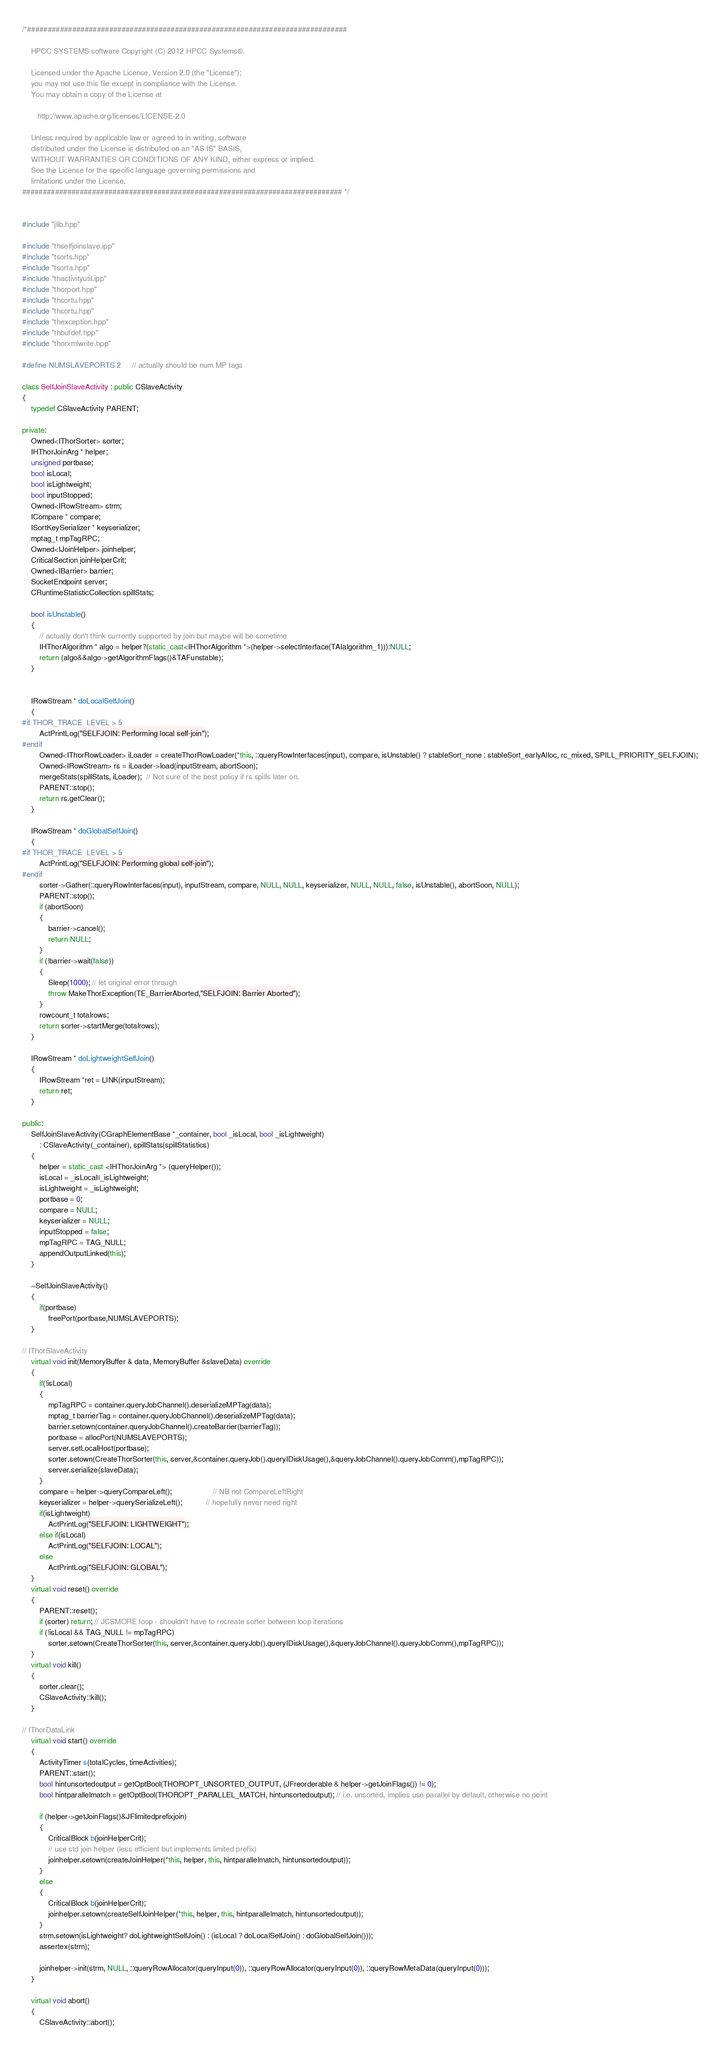<code> <loc_0><loc_0><loc_500><loc_500><_C++_>/*##############################################################################

    HPCC SYSTEMS software Copyright (C) 2012 HPCC Systems®.

    Licensed under the Apache License, Version 2.0 (the "License");
    you may not use this file except in compliance with the License.
    You may obtain a copy of the License at

       http://www.apache.org/licenses/LICENSE-2.0

    Unless required by applicable law or agreed to in writing, software
    distributed under the License is distributed on an "AS IS" BASIS,
    WITHOUT WARRANTIES OR CONDITIONS OF ANY KIND, either express or implied.
    See the License for the specific language governing permissions and
    limitations under the License.
############################################################################## */


#include "jlib.hpp"

#include "thselfjoinslave.ipp"
#include "tsorts.hpp"
#include "tsorta.hpp"
#include "thactivityutil.ipp"
#include "thorport.hpp"
#include "thsortu.hpp"
#include "thsortu.hpp"
#include "thexception.hpp"
#include "thbufdef.hpp"
#include "thorxmlwrite.hpp"

#define NUMSLAVEPORTS 2     // actually should be num MP tags

class SelfJoinSlaveActivity : public CSlaveActivity
{
    typedef CSlaveActivity PARENT;

private:
    Owned<IThorSorter> sorter;
    IHThorJoinArg * helper;
    unsigned portbase;
    bool isLocal;
    bool isLightweight;
    bool inputStopped;
    Owned<IRowStream> strm;     
    ICompare * compare;
    ISortKeySerializer * keyserializer;
    mptag_t mpTagRPC;
    Owned<IJoinHelper> joinhelper;
    CriticalSection joinHelperCrit;
    Owned<IBarrier> barrier;
    SocketEndpoint server;
    CRuntimeStatisticCollection spillStats;

    bool isUnstable()
    {
        // actually don't think currently supported by join but maybe will be sometime
        IHThorAlgorithm * algo = helper?(static_cast<IHThorAlgorithm *>(helper->selectInterface(TAIalgorithm_1))):NULL;
        return (algo&&algo->getAlgorithmFlags()&TAFunstable);
    }

    
    IRowStream * doLocalSelfJoin()
    {
#if THOR_TRACE_LEVEL > 5
        ActPrintLog("SELFJOIN: Performing local self-join");
#endif
        Owned<IThorRowLoader> iLoader = createThorRowLoader(*this, ::queryRowInterfaces(input), compare, isUnstable() ? stableSort_none : stableSort_earlyAlloc, rc_mixed, SPILL_PRIORITY_SELFJOIN);
        Owned<IRowStream> rs = iLoader->load(inputStream, abortSoon);
        mergeStats(spillStats, iLoader);  // Not sure of the best policy if rs spills later on.
        PARENT::stop();
        return rs.getClear();
    }

    IRowStream * doGlobalSelfJoin()
    {
#if THOR_TRACE_LEVEL > 5
        ActPrintLog("SELFJOIN: Performing global self-join");
#endif
        sorter->Gather(::queryRowInterfaces(input), inputStream, compare, NULL, NULL, keyserializer, NULL, NULL, false, isUnstable(), abortSoon, NULL);
        PARENT::stop();
        if (abortSoon)
        {
            barrier->cancel();
            return NULL;
        }
        if (!barrier->wait(false))
        {
            Sleep(1000); // let original error through
            throw MakeThorException(TE_BarrierAborted,"SELFJOIN: Barrier Aborted");
        }
        rowcount_t totalrows;
        return sorter->startMerge(totalrows);
    }

    IRowStream * doLightweightSelfJoin()
    {
        IRowStream *ret = LINK(inputStream);
        return ret;
    }

public:
    SelfJoinSlaveActivity(CGraphElementBase *_container, bool _isLocal, bool _isLightweight)
        : CSlaveActivity(_container), spillStats(spillStatistics)
    {
        helper = static_cast <IHThorJoinArg *> (queryHelper());
        isLocal = _isLocal||_isLightweight;
        isLightweight = _isLightweight;
        portbase = 0;
        compare = NULL;
        keyserializer = NULL;
        inputStopped = false;
        mpTagRPC = TAG_NULL;
        appendOutputLinked(this);
    }

    ~SelfJoinSlaveActivity()
    {
        if(portbase) 
            freePort(portbase,NUMSLAVEPORTS);
    }

// IThorSlaveActivity
    virtual void init(MemoryBuffer & data, MemoryBuffer &slaveData) override
    {       
        if(!isLocal)
        {
            mpTagRPC = container.queryJobChannel().deserializeMPTag(data);
            mptag_t barrierTag = container.queryJobChannel().deserializeMPTag(data);
            barrier.setown(container.queryJobChannel().createBarrier(barrierTag));
            portbase = allocPort(NUMSLAVEPORTS);
            server.setLocalHost(portbase);
            sorter.setown(CreateThorSorter(this, server,&container.queryJob().queryIDiskUsage(),&queryJobChannel().queryJobComm(),mpTagRPC));
            server.serialize(slaveData);
        }
        compare = helper->queryCompareLeft();                   // NB not CompareLeftRight
        keyserializer = helper->querySerializeLeft();           // hopefully never need right
        if(isLightweight) 
            ActPrintLog("SELFJOIN: LIGHTWEIGHT");
        else if(isLocal) 
            ActPrintLog("SELFJOIN: LOCAL");
        else
            ActPrintLog("SELFJOIN: GLOBAL");
    }
    virtual void reset() override
    {
        PARENT::reset();
        if (sorter) return; // JCSMORE loop - shouldn't have to recreate sorter between loop iterations
        if (!isLocal && TAG_NULL != mpTagRPC)
            sorter.setown(CreateThorSorter(this, server,&container.queryJob().queryIDiskUsage(),&queryJobChannel().queryJobComm(),mpTagRPC));
    }
    virtual void kill()
    {
        sorter.clear();
        CSlaveActivity::kill();
    }

// IThorDataLink
    virtual void start() override
    {
        ActivityTimer s(totalCycles, timeActivities);
        PARENT::start();
        bool hintunsortedoutput = getOptBool(THOROPT_UNSORTED_OUTPUT, (JFreorderable & helper->getJoinFlags()) != 0);
        bool hintparallelmatch = getOptBool(THOROPT_PARALLEL_MATCH, hintunsortedoutput); // i.e. unsorted, implies use parallel by default, otherwise no point

        if (helper->getJoinFlags()&JFlimitedprefixjoin)
        {
            CriticalBlock b(joinHelperCrit);
            // use std join helper (less efficient but implements limited prefix)
            joinhelper.setown(createJoinHelper(*this, helper, this, hintparallelmatch, hintunsortedoutput));
        }
        else
        {
            CriticalBlock b(joinHelperCrit);
            joinhelper.setown(createSelfJoinHelper(*this, helper, this, hintparallelmatch, hintunsortedoutput));
        }
        strm.setown(isLightweight? doLightweightSelfJoin() : (isLocal ? doLocalSelfJoin() : doGlobalSelfJoin()));
        assertex(strm);

        joinhelper->init(strm, NULL, ::queryRowAllocator(queryInput(0)), ::queryRowAllocator(queryInput(0)), ::queryRowMetaData(queryInput(0)));
    }

    virtual void abort()
    {
        CSlaveActivity::abort();</code> 